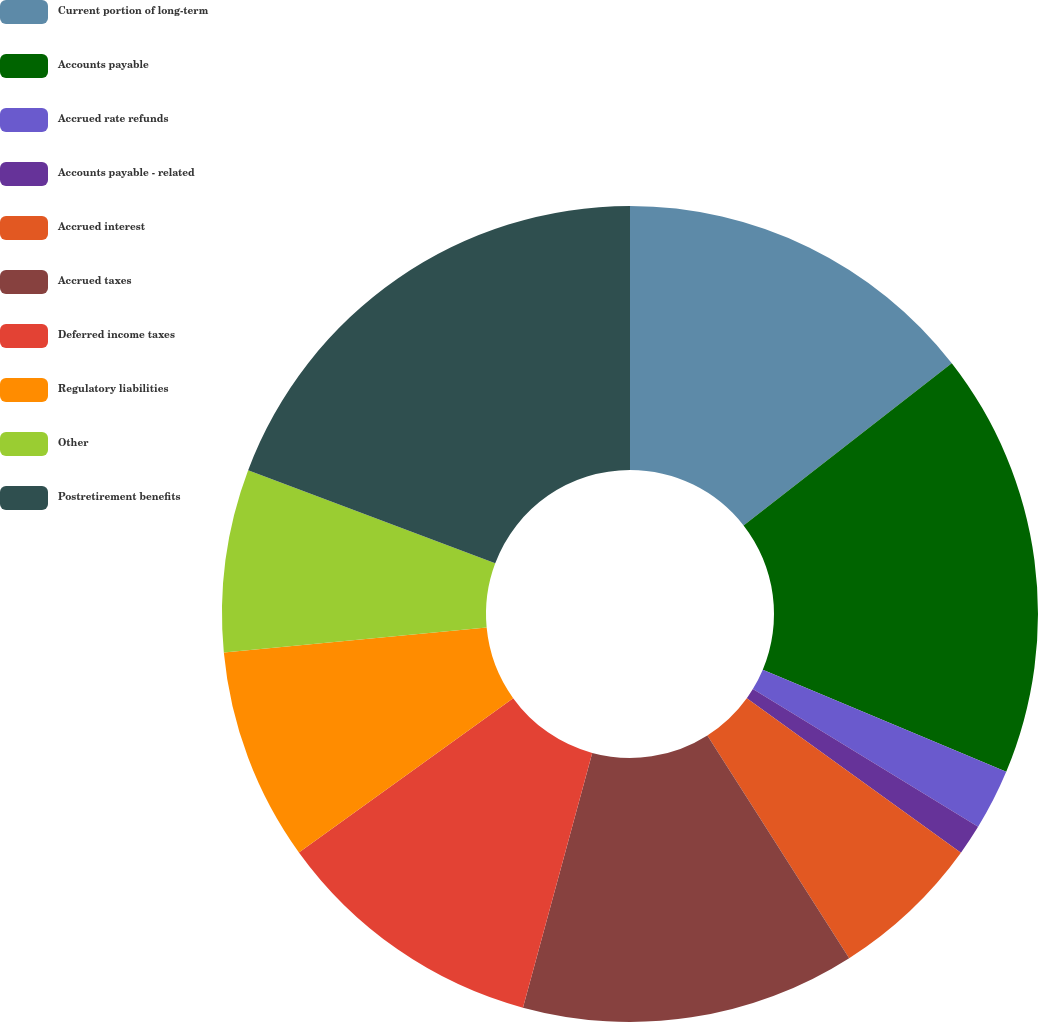Convert chart. <chart><loc_0><loc_0><loc_500><loc_500><pie_chart><fcel>Current portion of long-term<fcel>Accounts payable<fcel>Accrued rate refunds<fcel>Accounts payable - related<fcel>Accrued interest<fcel>Accrued taxes<fcel>Deferred income taxes<fcel>Regulatory liabilities<fcel>Other<fcel>Postretirement benefits<nl><fcel>14.46%<fcel>16.86%<fcel>2.41%<fcel>1.21%<fcel>6.03%<fcel>13.25%<fcel>10.84%<fcel>8.43%<fcel>7.23%<fcel>19.27%<nl></chart> 